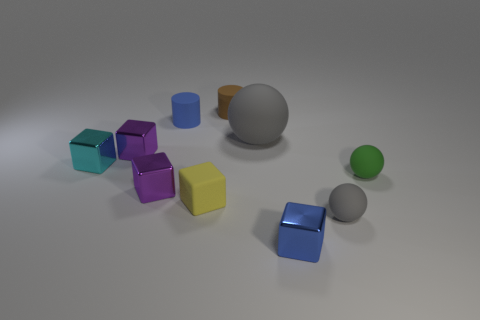Subtract all gray rubber balls. How many balls are left? 1 Subtract all blue balls. How many purple blocks are left? 2 Subtract 1 spheres. How many spheres are left? 2 Subtract all blue cylinders. How many cylinders are left? 1 Subtract all balls. How many objects are left? 7 Subtract 1 green spheres. How many objects are left? 9 Subtract all green blocks. Subtract all red cylinders. How many blocks are left? 5 Subtract all shiny blocks. Subtract all tiny matte spheres. How many objects are left? 4 Add 1 matte things. How many matte things are left? 7 Add 6 big metallic blocks. How many big metallic blocks exist? 6 